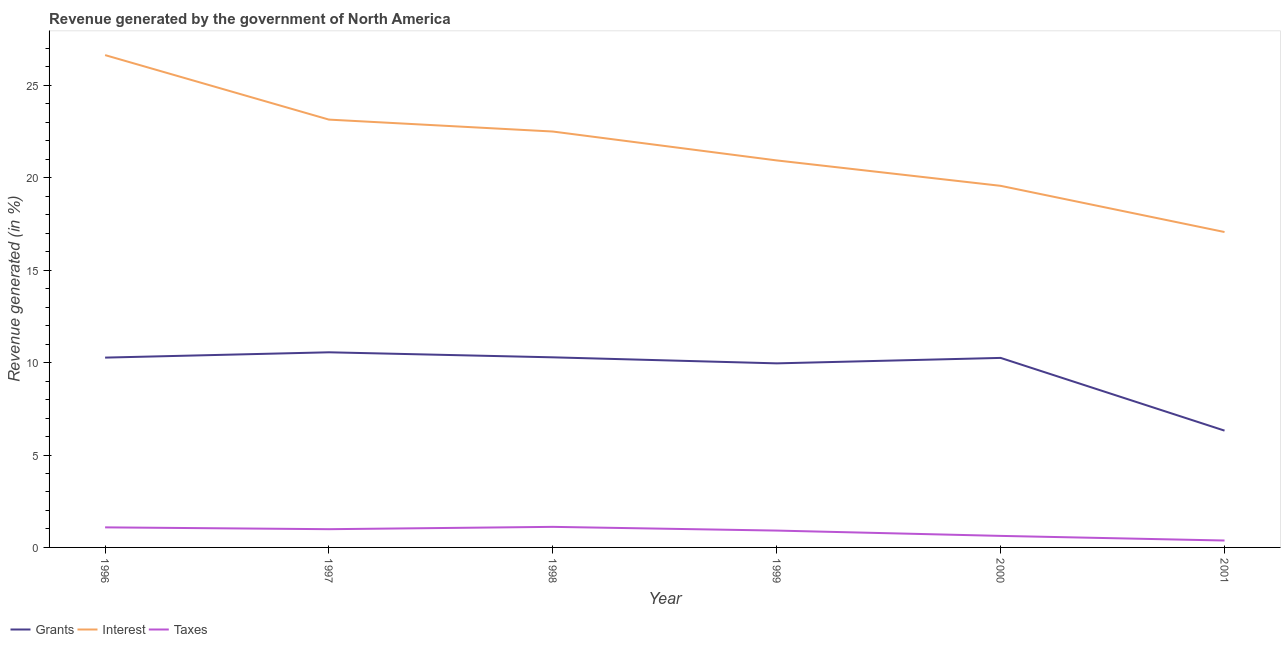Does the line corresponding to percentage of revenue generated by interest intersect with the line corresponding to percentage of revenue generated by grants?
Provide a succinct answer. No. Is the number of lines equal to the number of legend labels?
Provide a succinct answer. Yes. What is the percentage of revenue generated by interest in 1998?
Your response must be concise. 22.51. Across all years, what is the maximum percentage of revenue generated by grants?
Give a very brief answer. 10.56. Across all years, what is the minimum percentage of revenue generated by interest?
Offer a very short reply. 17.07. What is the total percentage of revenue generated by grants in the graph?
Keep it short and to the point. 57.65. What is the difference between the percentage of revenue generated by interest in 1997 and that in 2000?
Your response must be concise. 3.58. What is the difference between the percentage of revenue generated by grants in 1999 and the percentage of revenue generated by interest in 1996?
Give a very brief answer. -16.68. What is the average percentage of revenue generated by grants per year?
Make the answer very short. 9.61. In the year 2001, what is the difference between the percentage of revenue generated by interest and percentage of revenue generated by grants?
Provide a succinct answer. 10.75. What is the ratio of the percentage of revenue generated by grants in 1998 to that in 2001?
Offer a terse response. 1.63. What is the difference between the highest and the second highest percentage of revenue generated by interest?
Offer a very short reply. 3.49. What is the difference between the highest and the lowest percentage of revenue generated by interest?
Your response must be concise. 9.57. Is it the case that in every year, the sum of the percentage of revenue generated by grants and percentage of revenue generated by interest is greater than the percentage of revenue generated by taxes?
Make the answer very short. Yes. Does the percentage of revenue generated by taxes monotonically increase over the years?
Your answer should be compact. No. Is the percentage of revenue generated by grants strictly greater than the percentage of revenue generated by taxes over the years?
Give a very brief answer. Yes. What is the difference between two consecutive major ticks on the Y-axis?
Your answer should be compact. 5. Does the graph contain any zero values?
Provide a short and direct response. No. Where does the legend appear in the graph?
Your response must be concise. Bottom left. What is the title of the graph?
Your response must be concise. Revenue generated by the government of North America. What is the label or title of the X-axis?
Keep it short and to the point. Year. What is the label or title of the Y-axis?
Provide a succinct answer. Revenue generated (in %). What is the Revenue generated (in %) in Grants in 1996?
Keep it short and to the point. 10.27. What is the Revenue generated (in %) in Interest in 1996?
Your answer should be compact. 26.64. What is the Revenue generated (in %) in Taxes in 1996?
Your answer should be very brief. 1.09. What is the Revenue generated (in %) in Grants in 1997?
Provide a succinct answer. 10.56. What is the Revenue generated (in %) of Interest in 1997?
Your response must be concise. 23.15. What is the Revenue generated (in %) in Taxes in 1997?
Ensure brevity in your answer.  0.99. What is the Revenue generated (in %) in Grants in 1998?
Offer a terse response. 10.29. What is the Revenue generated (in %) of Interest in 1998?
Your answer should be compact. 22.51. What is the Revenue generated (in %) in Taxes in 1998?
Keep it short and to the point. 1.11. What is the Revenue generated (in %) in Grants in 1999?
Offer a terse response. 9.96. What is the Revenue generated (in %) of Interest in 1999?
Ensure brevity in your answer.  20.94. What is the Revenue generated (in %) of Taxes in 1999?
Offer a terse response. 0.91. What is the Revenue generated (in %) in Grants in 2000?
Your response must be concise. 10.26. What is the Revenue generated (in %) in Interest in 2000?
Your answer should be compact. 19.57. What is the Revenue generated (in %) of Taxes in 2000?
Provide a succinct answer. 0.62. What is the Revenue generated (in %) in Grants in 2001?
Provide a short and direct response. 6.32. What is the Revenue generated (in %) in Interest in 2001?
Provide a short and direct response. 17.07. What is the Revenue generated (in %) in Taxes in 2001?
Your response must be concise. 0.37. Across all years, what is the maximum Revenue generated (in %) in Grants?
Your response must be concise. 10.56. Across all years, what is the maximum Revenue generated (in %) in Interest?
Offer a very short reply. 26.64. Across all years, what is the maximum Revenue generated (in %) of Taxes?
Your response must be concise. 1.11. Across all years, what is the minimum Revenue generated (in %) of Grants?
Your answer should be very brief. 6.32. Across all years, what is the minimum Revenue generated (in %) in Interest?
Provide a succinct answer. 17.07. Across all years, what is the minimum Revenue generated (in %) of Taxes?
Offer a terse response. 0.37. What is the total Revenue generated (in %) in Grants in the graph?
Your response must be concise. 57.65. What is the total Revenue generated (in %) in Interest in the graph?
Your response must be concise. 129.87. What is the total Revenue generated (in %) in Taxes in the graph?
Your answer should be compact. 5.1. What is the difference between the Revenue generated (in %) of Grants in 1996 and that in 1997?
Your answer should be very brief. -0.29. What is the difference between the Revenue generated (in %) in Interest in 1996 and that in 1997?
Offer a terse response. 3.49. What is the difference between the Revenue generated (in %) in Taxes in 1996 and that in 1997?
Provide a short and direct response. 0.1. What is the difference between the Revenue generated (in %) of Grants in 1996 and that in 1998?
Your answer should be compact. -0.01. What is the difference between the Revenue generated (in %) of Interest in 1996 and that in 1998?
Ensure brevity in your answer.  4.14. What is the difference between the Revenue generated (in %) of Taxes in 1996 and that in 1998?
Provide a short and direct response. -0.03. What is the difference between the Revenue generated (in %) of Grants in 1996 and that in 1999?
Ensure brevity in your answer.  0.31. What is the difference between the Revenue generated (in %) in Interest in 1996 and that in 1999?
Your response must be concise. 5.7. What is the difference between the Revenue generated (in %) in Taxes in 1996 and that in 1999?
Your answer should be very brief. 0.17. What is the difference between the Revenue generated (in %) of Grants in 1996 and that in 2000?
Provide a short and direct response. 0.02. What is the difference between the Revenue generated (in %) in Interest in 1996 and that in 2000?
Give a very brief answer. 7.07. What is the difference between the Revenue generated (in %) in Taxes in 1996 and that in 2000?
Offer a very short reply. 0.46. What is the difference between the Revenue generated (in %) in Grants in 1996 and that in 2001?
Keep it short and to the point. 3.95. What is the difference between the Revenue generated (in %) in Interest in 1996 and that in 2001?
Keep it short and to the point. 9.57. What is the difference between the Revenue generated (in %) in Taxes in 1996 and that in 2001?
Keep it short and to the point. 0.71. What is the difference between the Revenue generated (in %) in Grants in 1997 and that in 1998?
Your response must be concise. 0.27. What is the difference between the Revenue generated (in %) in Interest in 1997 and that in 1998?
Keep it short and to the point. 0.65. What is the difference between the Revenue generated (in %) of Taxes in 1997 and that in 1998?
Your answer should be compact. -0.13. What is the difference between the Revenue generated (in %) of Grants in 1997 and that in 1999?
Offer a very short reply. 0.6. What is the difference between the Revenue generated (in %) in Interest in 1997 and that in 1999?
Provide a short and direct response. 2.21. What is the difference between the Revenue generated (in %) in Taxes in 1997 and that in 1999?
Make the answer very short. 0.08. What is the difference between the Revenue generated (in %) in Grants in 1997 and that in 2000?
Provide a short and direct response. 0.3. What is the difference between the Revenue generated (in %) in Interest in 1997 and that in 2000?
Make the answer very short. 3.58. What is the difference between the Revenue generated (in %) in Taxes in 1997 and that in 2000?
Provide a short and direct response. 0.36. What is the difference between the Revenue generated (in %) of Grants in 1997 and that in 2001?
Provide a succinct answer. 4.24. What is the difference between the Revenue generated (in %) in Interest in 1997 and that in 2001?
Provide a succinct answer. 6.08. What is the difference between the Revenue generated (in %) in Taxes in 1997 and that in 2001?
Give a very brief answer. 0.61. What is the difference between the Revenue generated (in %) of Grants in 1998 and that in 1999?
Your answer should be compact. 0.33. What is the difference between the Revenue generated (in %) in Interest in 1998 and that in 1999?
Provide a succinct answer. 1.56. What is the difference between the Revenue generated (in %) of Taxes in 1998 and that in 1999?
Your response must be concise. 0.2. What is the difference between the Revenue generated (in %) of Grants in 1998 and that in 2000?
Ensure brevity in your answer.  0.03. What is the difference between the Revenue generated (in %) in Interest in 1998 and that in 2000?
Make the answer very short. 2.94. What is the difference between the Revenue generated (in %) in Taxes in 1998 and that in 2000?
Provide a succinct answer. 0.49. What is the difference between the Revenue generated (in %) in Grants in 1998 and that in 2001?
Give a very brief answer. 3.97. What is the difference between the Revenue generated (in %) of Interest in 1998 and that in 2001?
Offer a very short reply. 5.44. What is the difference between the Revenue generated (in %) of Taxes in 1998 and that in 2001?
Your answer should be compact. 0.74. What is the difference between the Revenue generated (in %) in Grants in 1999 and that in 2000?
Your answer should be compact. -0.29. What is the difference between the Revenue generated (in %) of Interest in 1999 and that in 2000?
Offer a very short reply. 1.37. What is the difference between the Revenue generated (in %) of Taxes in 1999 and that in 2000?
Make the answer very short. 0.29. What is the difference between the Revenue generated (in %) of Grants in 1999 and that in 2001?
Offer a very short reply. 3.64. What is the difference between the Revenue generated (in %) of Interest in 1999 and that in 2001?
Your answer should be very brief. 3.87. What is the difference between the Revenue generated (in %) of Taxes in 1999 and that in 2001?
Offer a terse response. 0.54. What is the difference between the Revenue generated (in %) in Grants in 2000 and that in 2001?
Keep it short and to the point. 3.94. What is the difference between the Revenue generated (in %) in Interest in 2000 and that in 2001?
Keep it short and to the point. 2.5. What is the difference between the Revenue generated (in %) in Taxes in 2000 and that in 2001?
Your answer should be very brief. 0.25. What is the difference between the Revenue generated (in %) in Grants in 1996 and the Revenue generated (in %) in Interest in 1997?
Your response must be concise. -12.88. What is the difference between the Revenue generated (in %) of Grants in 1996 and the Revenue generated (in %) of Taxes in 1997?
Your answer should be very brief. 9.28. What is the difference between the Revenue generated (in %) in Interest in 1996 and the Revenue generated (in %) in Taxes in 1997?
Give a very brief answer. 25.65. What is the difference between the Revenue generated (in %) of Grants in 1996 and the Revenue generated (in %) of Interest in 1998?
Give a very brief answer. -12.23. What is the difference between the Revenue generated (in %) of Grants in 1996 and the Revenue generated (in %) of Taxes in 1998?
Make the answer very short. 9.16. What is the difference between the Revenue generated (in %) of Interest in 1996 and the Revenue generated (in %) of Taxes in 1998?
Make the answer very short. 25.53. What is the difference between the Revenue generated (in %) in Grants in 1996 and the Revenue generated (in %) in Interest in 1999?
Your answer should be very brief. -10.67. What is the difference between the Revenue generated (in %) of Grants in 1996 and the Revenue generated (in %) of Taxes in 1999?
Provide a short and direct response. 9.36. What is the difference between the Revenue generated (in %) of Interest in 1996 and the Revenue generated (in %) of Taxes in 1999?
Your response must be concise. 25.73. What is the difference between the Revenue generated (in %) of Grants in 1996 and the Revenue generated (in %) of Interest in 2000?
Your answer should be very brief. -9.3. What is the difference between the Revenue generated (in %) of Grants in 1996 and the Revenue generated (in %) of Taxes in 2000?
Ensure brevity in your answer.  9.65. What is the difference between the Revenue generated (in %) of Interest in 1996 and the Revenue generated (in %) of Taxes in 2000?
Make the answer very short. 26.02. What is the difference between the Revenue generated (in %) of Grants in 1996 and the Revenue generated (in %) of Interest in 2001?
Offer a terse response. -6.8. What is the difference between the Revenue generated (in %) of Grants in 1996 and the Revenue generated (in %) of Taxes in 2001?
Keep it short and to the point. 9.9. What is the difference between the Revenue generated (in %) of Interest in 1996 and the Revenue generated (in %) of Taxes in 2001?
Offer a terse response. 26.27. What is the difference between the Revenue generated (in %) of Grants in 1997 and the Revenue generated (in %) of Interest in 1998?
Provide a succinct answer. -11.95. What is the difference between the Revenue generated (in %) of Grants in 1997 and the Revenue generated (in %) of Taxes in 1998?
Ensure brevity in your answer.  9.45. What is the difference between the Revenue generated (in %) of Interest in 1997 and the Revenue generated (in %) of Taxes in 1998?
Offer a very short reply. 22.04. What is the difference between the Revenue generated (in %) in Grants in 1997 and the Revenue generated (in %) in Interest in 1999?
Ensure brevity in your answer.  -10.38. What is the difference between the Revenue generated (in %) in Grants in 1997 and the Revenue generated (in %) in Taxes in 1999?
Keep it short and to the point. 9.65. What is the difference between the Revenue generated (in %) in Interest in 1997 and the Revenue generated (in %) in Taxes in 1999?
Your response must be concise. 22.24. What is the difference between the Revenue generated (in %) of Grants in 1997 and the Revenue generated (in %) of Interest in 2000?
Offer a very short reply. -9.01. What is the difference between the Revenue generated (in %) of Grants in 1997 and the Revenue generated (in %) of Taxes in 2000?
Provide a succinct answer. 9.93. What is the difference between the Revenue generated (in %) of Interest in 1997 and the Revenue generated (in %) of Taxes in 2000?
Keep it short and to the point. 22.53. What is the difference between the Revenue generated (in %) in Grants in 1997 and the Revenue generated (in %) in Interest in 2001?
Provide a short and direct response. -6.51. What is the difference between the Revenue generated (in %) of Grants in 1997 and the Revenue generated (in %) of Taxes in 2001?
Ensure brevity in your answer.  10.18. What is the difference between the Revenue generated (in %) in Interest in 1997 and the Revenue generated (in %) in Taxes in 2001?
Offer a terse response. 22.78. What is the difference between the Revenue generated (in %) of Grants in 1998 and the Revenue generated (in %) of Interest in 1999?
Provide a short and direct response. -10.66. What is the difference between the Revenue generated (in %) in Grants in 1998 and the Revenue generated (in %) in Taxes in 1999?
Offer a terse response. 9.38. What is the difference between the Revenue generated (in %) in Interest in 1998 and the Revenue generated (in %) in Taxes in 1999?
Ensure brevity in your answer.  21.59. What is the difference between the Revenue generated (in %) in Grants in 1998 and the Revenue generated (in %) in Interest in 2000?
Provide a short and direct response. -9.28. What is the difference between the Revenue generated (in %) in Grants in 1998 and the Revenue generated (in %) in Taxes in 2000?
Your response must be concise. 9.66. What is the difference between the Revenue generated (in %) of Interest in 1998 and the Revenue generated (in %) of Taxes in 2000?
Keep it short and to the point. 21.88. What is the difference between the Revenue generated (in %) of Grants in 1998 and the Revenue generated (in %) of Interest in 2001?
Ensure brevity in your answer.  -6.78. What is the difference between the Revenue generated (in %) in Grants in 1998 and the Revenue generated (in %) in Taxes in 2001?
Offer a very short reply. 9.91. What is the difference between the Revenue generated (in %) in Interest in 1998 and the Revenue generated (in %) in Taxes in 2001?
Keep it short and to the point. 22.13. What is the difference between the Revenue generated (in %) of Grants in 1999 and the Revenue generated (in %) of Interest in 2000?
Your answer should be very brief. -9.61. What is the difference between the Revenue generated (in %) in Grants in 1999 and the Revenue generated (in %) in Taxes in 2000?
Give a very brief answer. 9.34. What is the difference between the Revenue generated (in %) in Interest in 1999 and the Revenue generated (in %) in Taxes in 2000?
Your answer should be very brief. 20.32. What is the difference between the Revenue generated (in %) of Grants in 1999 and the Revenue generated (in %) of Interest in 2001?
Ensure brevity in your answer.  -7.11. What is the difference between the Revenue generated (in %) in Grants in 1999 and the Revenue generated (in %) in Taxes in 2001?
Make the answer very short. 9.59. What is the difference between the Revenue generated (in %) of Interest in 1999 and the Revenue generated (in %) of Taxes in 2001?
Your response must be concise. 20.57. What is the difference between the Revenue generated (in %) of Grants in 2000 and the Revenue generated (in %) of Interest in 2001?
Provide a short and direct response. -6.81. What is the difference between the Revenue generated (in %) in Grants in 2000 and the Revenue generated (in %) in Taxes in 2001?
Offer a terse response. 9.88. What is the difference between the Revenue generated (in %) in Interest in 2000 and the Revenue generated (in %) in Taxes in 2001?
Your answer should be compact. 19.19. What is the average Revenue generated (in %) of Grants per year?
Your answer should be compact. 9.61. What is the average Revenue generated (in %) of Interest per year?
Your response must be concise. 21.65. What is the average Revenue generated (in %) of Taxes per year?
Your answer should be compact. 0.85. In the year 1996, what is the difference between the Revenue generated (in %) of Grants and Revenue generated (in %) of Interest?
Provide a succinct answer. -16.37. In the year 1996, what is the difference between the Revenue generated (in %) in Grants and Revenue generated (in %) in Taxes?
Keep it short and to the point. 9.19. In the year 1996, what is the difference between the Revenue generated (in %) in Interest and Revenue generated (in %) in Taxes?
Your answer should be very brief. 25.55. In the year 1997, what is the difference between the Revenue generated (in %) of Grants and Revenue generated (in %) of Interest?
Offer a terse response. -12.59. In the year 1997, what is the difference between the Revenue generated (in %) of Grants and Revenue generated (in %) of Taxes?
Offer a very short reply. 9.57. In the year 1997, what is the difference between the Revenue generated (in %) in Interest and Revenue generated (in %) in Taxes?
Your answer should be compact. 22.16. In the year 1998, what is the difference between the Revenue generated (in %) of Grants and Revenue generated (in %) of Interest?
Your answer should be compact. -12.22. In the year 1998, what is the difference between the Revenue generated (in %) of Grants and Revenue generated (in %) of Taxes?
Offer a terse response. 9.17. In the year 1998, what is the difference between the Revenue generated (in %) of Interest and Revenue generated (in %) of Taxes?
Keep it short and to the point. 21.39. In the year 1999, what is the difference between the Revenue generated (in %) of Grants and Revenue generated (in %) of Interest?
Offer a very short reply. -10.98. In the year 1999, what is the difference between the Revenue generated (in %) of Grants and Revenue generated (in %) of Taxes?
Provide a succinct answer. 9.05. In the year 1999, what is the difference between the Revenue generated (in %) of Interest and Revenue generated (in %) of Taxes?
Your answer should be very brief. 20.03. In the year 2000, what is the difference between the Revenue generated (in %) in Grants and Revenue generated (in %) in Interest?
Ensure brevity in your answer.  -9.31. In the year 2000, what is the difference between the Revenue generated (in %) of Grants and Revenue generated (in %) of Taxes?
Your response must be concise. 9.63. In the year 2000, what is the difference between the Revenue generated (in %) in Interest and Revenue generated (in %) in Taxes?
Offer a very short reply. 18.94. In the year 2001, what is the difference between the Revenue generated (in %) in Grants and Revenue generated (in %) in Interest?
Make the answer very short. -10.75. In the year 2001, what is the difference between the Revenue generated (in %) in Grants and Revenue generated (in %) in Taxes?
Offer a terse response. 5.95. In the year 2001, what is the difference between the Revenue generated (in %) in Interest and Revenue generated (in %) in Taxes?
Offer a terse response. 16.69. What is the ratio of the Revenue generated (in %) of Grants in 1996 to that in 1997?
Offer a very short reply. 0.97. What is the ratio of the Revenue generated (in %) of Interest in 1996 to that in 1997?
Your answer should be compact. 1.15. What is the ratio of the Revenue generated (in %) of Taxes in 1996 to that in 1997?
Your answer should be very brief. 1.1. What is the ratio of the Revenue generated (in %) in Grants in 1996 to that in 1998?
Provide a succinct answer. 1. What is the ratio of the Revenue generated (in %) of Interest in 1996 to that in 1998?
Give a very brief answer. 1.18. What is the ratio of the Revenue generated (in %) in Grants in 1996 to that in 1999?
Provide a short and direct response. 1.03. What is the ratio of the Revenue generated (in %) of Interest in 1996 to that in 1999?
Keep it short and to the point. 1.27. What is the ratio of the Revenue generated (in %) in Taxes in 1996 to that in 1999?
Offer a terse response. 1.19. What is the ratio of the Revenue generated (in %) in Interest in 1996 to that in 2000?
Your response must be concise. 1.36. What is the ratio of the Revenue generated (in %) of Taxes in 1996 to that in 2000?
Keep it short and to the point. 1.74. What is the ratio of the Revenue generated (in %) of Grants in 1996 to that in 2001?
Offer a terse response. 1.63. What is the ratio of the Revenue generated (in %) in Interest in 1996 to that in 2001?
Make the answer very short. 1.56. What is the ratio of the Revenue generated (in %) of Taxes in 1996 to that in 2001?
Your response must be concise. 2.9. What is the ratio of the Revenue generated (in %) in Grants in 1997 to that in 1998?
Provide a succinct answer. 1.03. What is the ratio of the Revenue generated (in %) of Interest in 1997 to that in 1998?
Provide a short and direct response. 1.03. What is the ratio of the Revenue generated (in %) in Taxes in 1997 to that in 1998?
Offer a terse response. 0.89. What is the ratio of the Revenue generated (in %) of Grants in 1997 to that in 1999?
Provide a short and direct response. 1.06. What is the ratio of the Revenue generated (in %) of Interest in 1997 to that in 1999?
Offer a terse response. 1.11. What is the ratio of the Revenue generated (in %) in Taxes in 1997 to that in 1999?
Offer a very short reply. 1.08. What is the ratio of the Revenue generated (in %) of Grants in 1997 to that in 2000?
Your answer should be very brief. 1.03. What is the ratio of the Revenue generated (in %) of Interest in 1997 to that in 2000?
Your answer should be compact. 1.18. What is the ratio of the Revenue generated (in %) of Taxes in 1997 to that in 2000?
Provide a short and direct response. 1.58. What is the ratio of the Revenue generated (in %) in Grants in 1997 to that in 2001?
Give a very brief answer. 1.67. What is the ratio of the Revenue generated (in %) of Interest in 1997 to that in 2001?
Offer a very short reply. 1.36. What is the ratio of the Revenue generated (in %) of Taxes in 1997 to that in 2001?
Make the answer very short. 2.64. What is the ratio of the Revenue generated (in %) in Grants in 1998 to that in 1999?
Your answer should be compact. 1.03. What is the ratio of the Revenue generated (in %) in Interest in 1998 to that in 1999?
Your answer should be compact. 1.07. What is the ratio of the Revenue generated (in %) in Taxes in 1998 to that in 1999?
Provide a short and direct response. 1.22. What is the ratio of the Revenue generated (in %) in Grants in 1998 to that in 2000?
Provide a short and direct response. 1. What is the ratio of the Revenue generated (in %) of Interest in 1998 to that in 2000?
Your answer should be compact. 1.15. What is the ratio of the Revenue generated (in %) in Taxes in 1998 to that in 2000?
Provide a succinct answer. 1.78. What is the ratio of the Revenue generated (in %) of Grants in 1998 to that in 2001?
Your answer should be compact. 1.63. What is the ratio of the Revenue generated (in %) in Interest in 1998 to that in 2001?
Give a very brief answer. 1.32. What is the ratio of the Revenue generated (in %) of Taxes in 1998 to that in 2001?
Provide a succinct answer. 2.97. What is the ratio of the Revenue generated (in %) of Grants in 1999 to that in 2000?
Your answer should be compact. 0.97. What is the ratio of the Revenue generated (in %) in Interest in 1999 to that in 2000?
Offer a terse response. 1.07. What is the ratio of the Revenue generated (in %) in Taxes in 1999 to that in 2000?
Make the answer very short. 1.46. What is the ratio of the Revenue generated (in %) of Grants in 1999 to that in 2001?
Offer a terse response. 1.58. What is the ratio of the Revenue generated (in %) in Interest in 1999 to that in 2001?
Give a very brief answer. 1.23. What is the ratio of the Revenue generated (in %) in Taxes in 1999 to that in 2001?
Ensure brevity in your answer.  2.44. What is the ratio of the Revenue generated (in %) in Grants in 2000 to that in 2001?
Provide a short and direct response. 1.62. What is the ratio of the Revenue generated (in %) of Interest in 2000 to that in 2001?
Your response must be concise. 1.15. What is the ratio of the Revenue generated (in %) in Taxes in 2000 to that in 2001?
Keep it short and to the point. 1.67. What is the difference between the highest and the second highest Revenue generated (in %) in Grants?
Provide a succinct answer. 0.27. What is the difference between the highest and the second highest Revenue generated (in %) of Interest?
Keep it short and to the point. 3.49. What is the difference between the highest and the second highest Revenue generated (in %) of Taxes?
Your response must be concise. 0.03. What is the difference between the highest and the lowest Revenue generated (in %) in Grants?
Ensure brevity in your answer.  4.24. What is the difference between the highest and the lowest Revenue generated (in %) of Interest?
Provide a succinct answer. 9.57. What is the difference between the highest and the lowest Revenue generated (in %) in Taxes?
Your answer should be compact. 0.74. 